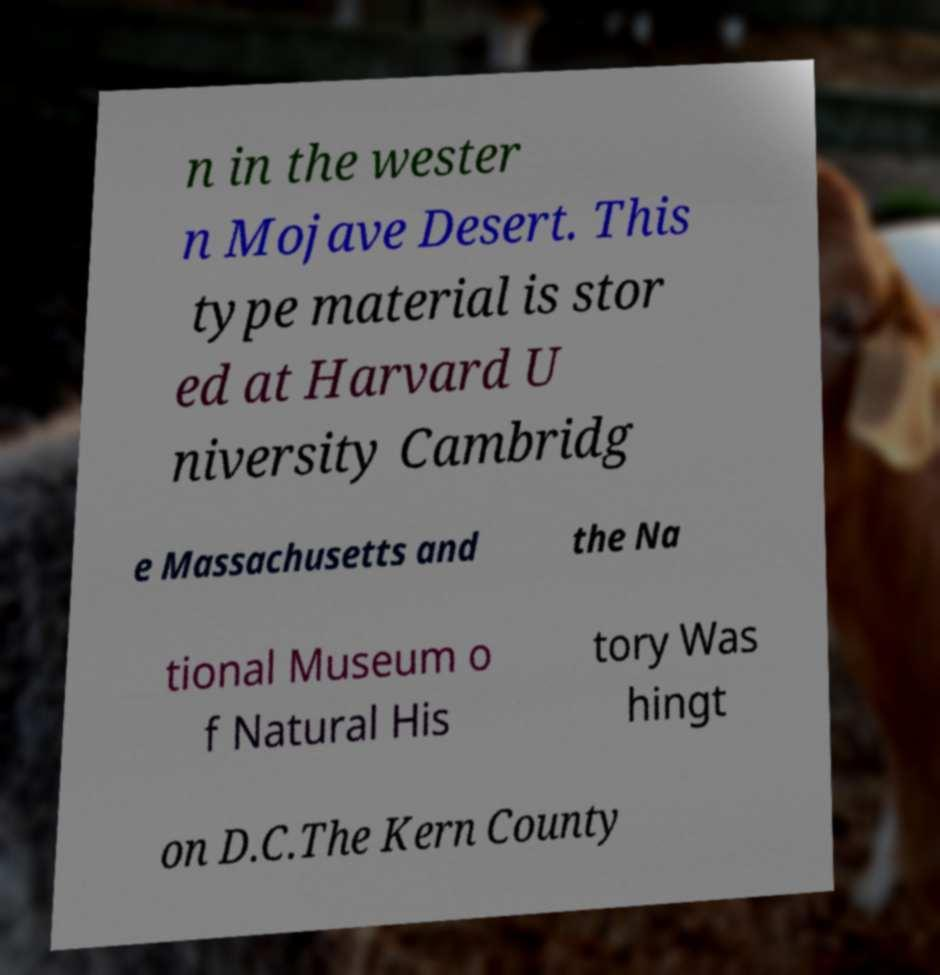I need the written content from this picture converted into text. Can you do that? n in the wester n Mojave Desert. This type material is stor ed at Harvard U niversity Cambridg e Massachusetts and the Na tional Museum o f Natural His tory Was hingt on D.C.The Kern County 